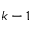<formula> <loc_0><loc_0><loc_500><loc_500>k - 1</formula> 